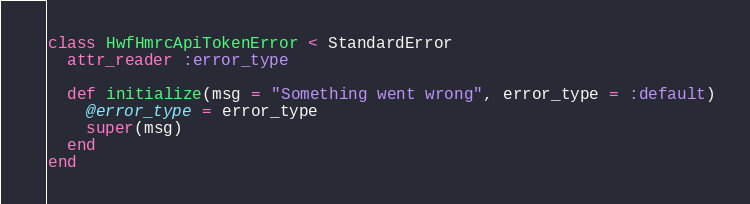Convert code to text. <code><loc_0><loc_0><loc_500><loc_500><_Ruby_>class HwfHmrcApiTokenError < StandardError
  attr_reader :error_type

  def initialize(msg = "Something went wrong", error_type = :default)
    @error_type = error_type
    super(msg)
  end
end
</code> 